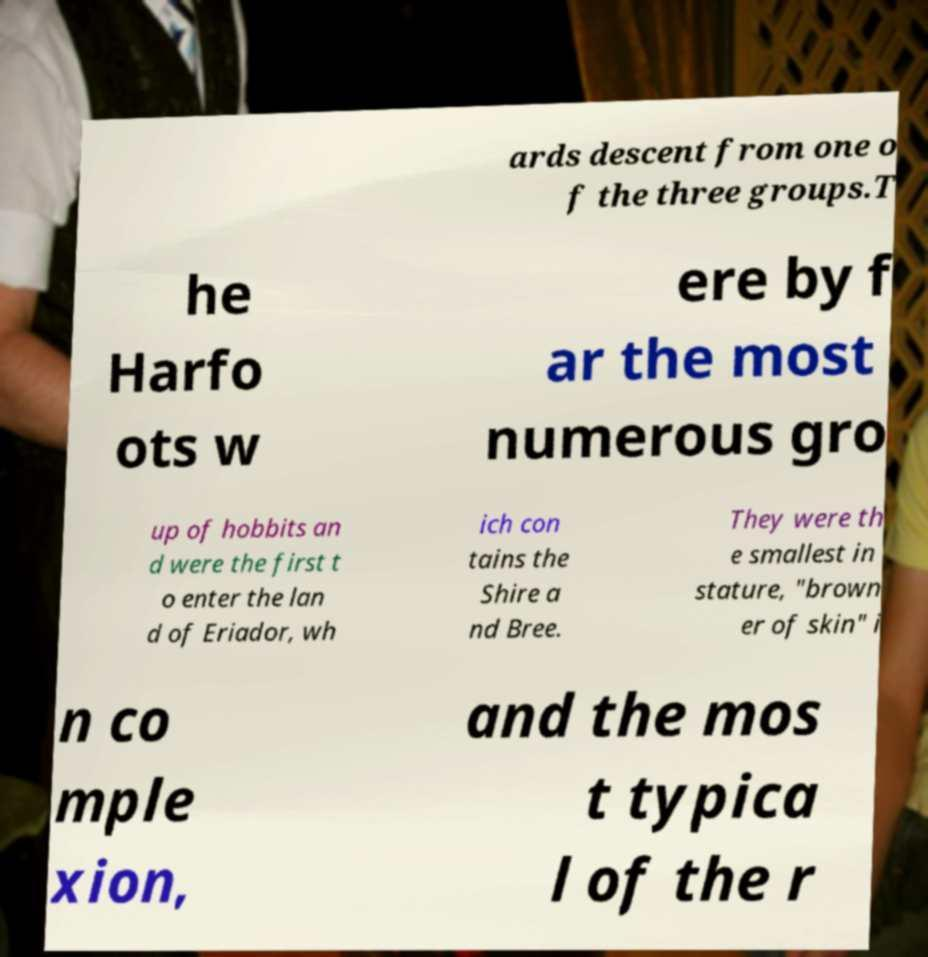Could you extract and type out the text from this image? ards descent from one o f the three groups.T he Harfo ots w ere by f ar the most numerous gro up of hobbits an d were the first t o enter the lan d of Eriador, wh ich con tains the Shire a nd Bree. They were th e smallest in stature, "brown er of skin" i n co mple xion, and the mos t typica l of the r 